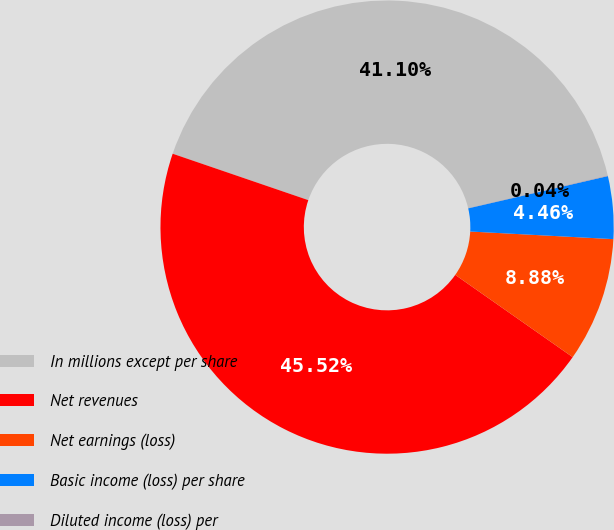Convert chart to OTSL. <chart><loc_0><loc_0><loc_500><loc_500><pie_chart><fcel>In millions except per share<fcel>Net revenues<fcel>Net earnings (loss)<fcel>Basic income (loss) per share<fcel>Diluted income (loss) per<nl><fcel>41.1%<fcel>45.52%<fcel>8.88%<fcel>4.46%<fcel>0.04%<nl></chart> 